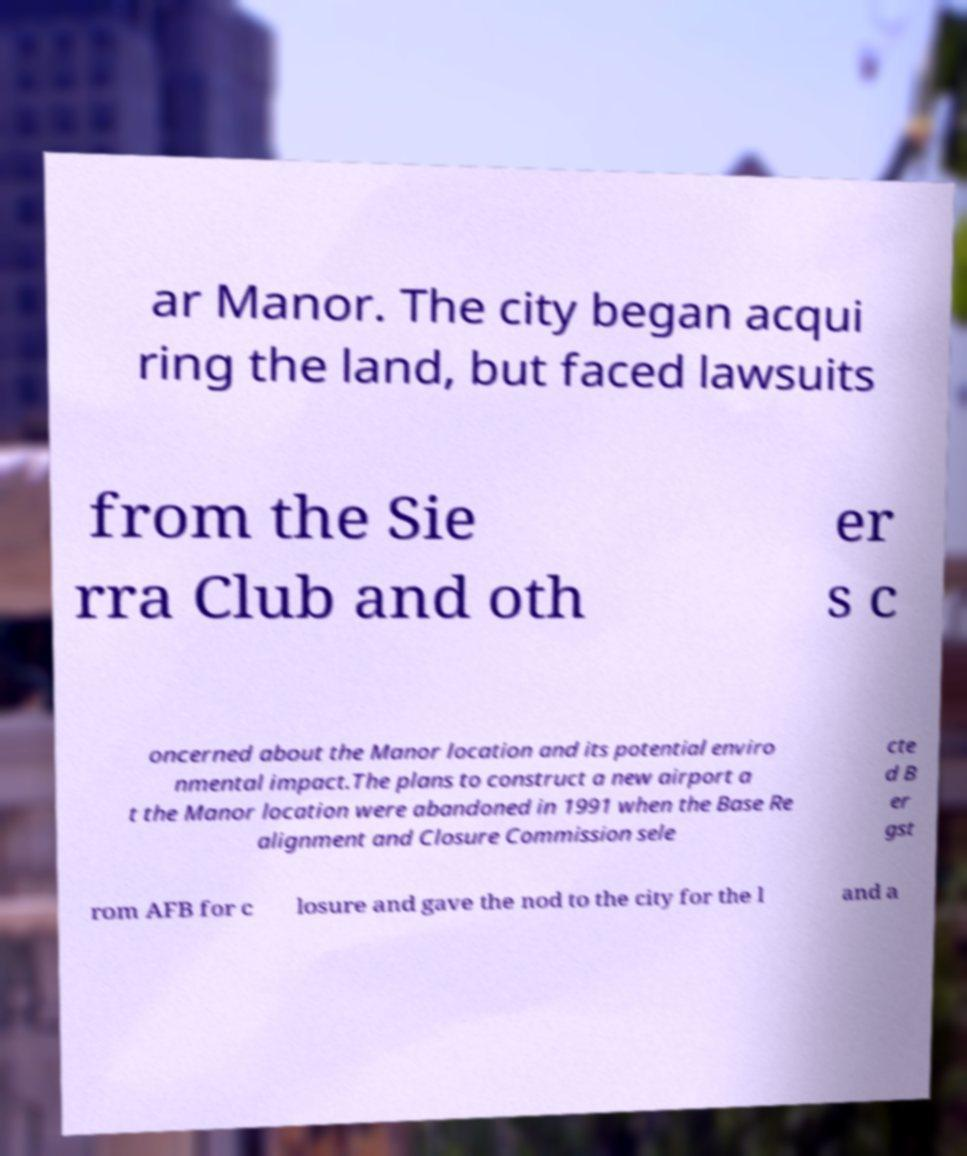Can you read and provide the text displayed in the image?This photo seems to have some interesting text. Can you extract and type it out for me? ar Manor. The city began acqui ring the land, but faced lawsuits from the Sie rra Club and oth er s c oncerned about the Manor location and its potential enviro nmental impact.The plans to construct a new airport a t the Manor location were abandoned in 1991 when the Base Re alignment and Closure Commission sele cte d B er gst rom AFB for c losure and gave the nod to the city for the l and a 